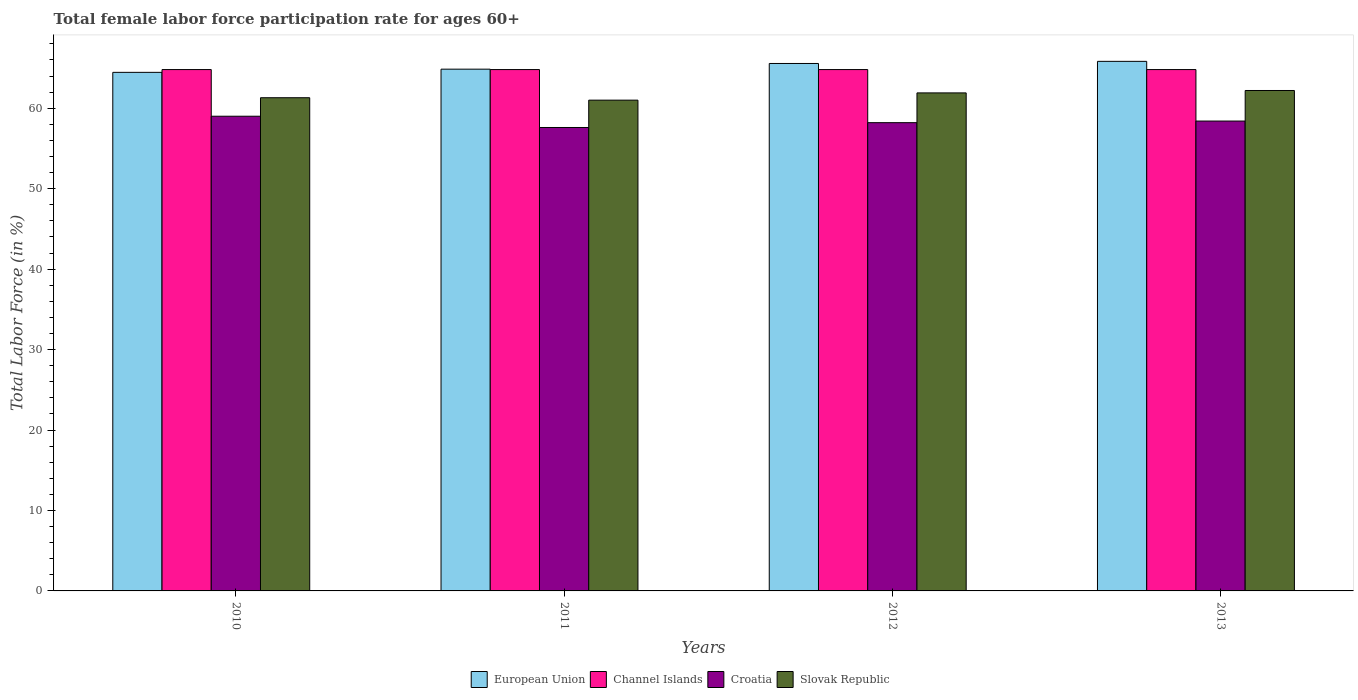How many different coloured bars are there?
Your answer should be very brief. 4. How many bars are there on the 2nd tick from the left?
Keep it short and to the point. 4. How many bars are there on the 2nd tick from the right?
Offer a very short reply. 4. What is the label of the 3rd group of bars from the left?
Your answer should be very brief. 2012. Across all years, what is the maximum female labor force participation rate in Slovak Republic?
Provide a succinct answer. 62.2. Across all years, what is the minimum female labor force participation rate in Croatia?
Offer a terse response. 57.6. In which year was the female labor force participation rate in Croatia maximum?
Ensure brevity in your answer.  2010. In which year was the female labor force participation rate in Croatia minimum?
Ensure brevity in your answer.  2011. What is the total female labor force participation rate in Channel Islands in the graph?
Offer a terse response. 259.2. What is the difference between the female labor force participation rate in European Union in 2011 and that in 2013?
Your response must be concise. -0.97. What is the difference between the female labor force participation rate in Channel Islands in 2010 and the female labor force participation rate in Croatia in 2013?
Your answer should be very brief. 6.4. What is the average female labor force participation rate in European Union per year?
Keep it short and to the point. 65.17. In the year 2012, what is the difference between the female labor force participation rate in Channel Islands and female labor force participation rate in European Union?
Your answer should be very brief. -0.76. In how many years, is the female labor force participation rate in Slovak Republic greater than 54 %?
Keep it short and to the point. 4. What is the ratio of the female labor force participation rate in Slovak Republic in 2010 to that in 2012?
Your response must be concise. 0.99. Is the female labor force participation rate in Slovak Republic in 2010 less than that in 2011?
Your answer should be compact. No. What is the difference between the highest and the second highest female labor force participation rate in Croatia?
Offer a terse response. 0.6. What is the difference between the highest and the lowest female labor force participation rate in Croatia?
Provide a short and direct response. 1.4. In how many years, is the female labor force participation rate in Channel Islands greater than the average female labor force participation rate in Channel Islands taken over all years?
Your answer should be compact. 0. Is the sum of the female labor force participation rate in Slovak Republic in 2010 and 2011 greater than the maximum female labor force participation rate in Channel Islands across all years?
Keep it short and to the point. Yes. What does the 4th bar from the left in 2010 represents?
Your response must be concise. Slovak Republic. Is it the case that in every year, the sum of the female labor force participation rate in European Union and female labor force participation rate in Slovak Republic is greater than the female labor force participation rate in Channel Islands?
Keep it short and to the point. Yes. Does the graph contain grids?
Give a very brief answer. No. What is the title of the graph?
Provide a short and direct response. Total female labor force participation rate for ages 60+. Does "Mexico" appear as one of the legend labels in the graph?
Make the answer very short. No. What is the label or title of the Y-axis?
Offer a terse response. Total Labor Force (in %). What is the Total Labor Force (in %) of European Union in 2010?
Make the answer very short. 64.45. What is the Total Labor Force (in %) of Channel Islands in 2010?
Provide a short and direct response. 64.8. What is the Total Labor Force (in %) of Croatia in 2010?
Your answer should be compact. 59. What is the Total Labor Force (in %) of Slovak Republic in 2010?
Offer a terse response. 61.3. What is the Total Labor Force (in %) of European Union in 2011?
Offer a very short reply. 64.85. What is the Total Labor Force (in %) in Channel Islands in 2011?
Ensure brevity in your answer.  64.8. What is the Total Labor Force (in %) in Croatia in 2011?
Ensure brevity in your answer.  57.6. What is the Total Labor Force (in %) in Slovak Republic in 2011?
Your answer should be very brief. 61. What is the Total Labor Force (in %) of European Union in 2012?
Offer a terse response. 65.56. What is the Total Labor Force (in %) of Channel Islands in 2012?
Give a very brief answer. 64.8. What is the Total Labor Force (in %) in Croatia in 2012?
Provide a succinct answer. 58.2. What is the Total Labor Force (in %) of Slovak Republic in 2012?
Your answer should be very brief. 61.9. What is the Total Labor Force (in %) in European Union in 2013?
Your answer should be very brief. 65.82. What is the Total Labor Force (in %) in Channel Islands in 2013?
Provide a short and direct response. 64.8. What is the Total Labor Force (in %) of Croatia in 2013?
Give a very brief answer. 58.4. What is the Total Labor Force (in %) of Slovak Republic in 2013?
Offer a terse response. 62.2. Across all years, what is the maximum Total Labor Force (in %) of European Union?
Your response must be concise. 65.82. Across all years, what is the maximum Total Labor Force (in %) in Channel Islands?
Give a very brief answer. 64.8. Across all years, what is the maximum Total Labor Force (in %) in Croatia?
Provide a succinct answer. 59. Across all years, what is the maximum Total Labor Force (in %) of Slovak Republic?
Keep it short and to the point. 62.2. Across all years, what is the minimum Total Labor Force (in %) in European Union?
Give a very brief answer. 64.45. Across all years, what is the minimum Total Labor Force (in %) of Channel Islands?
Provide a short and direct response. 64.8. Across all years, what is the minimum Total Labor Force (in %) of Croatia?
Give a very brief answer. 57.6. Across all years, what is the minimum Total Labor Force (in %) in Slovak Republic?
Provide a short and direct response. 61. What is the total Total Labor Force (in %) in European Union in the graph?
Ensure brevity in your answer.  260.68. What is the total Total Labor Force (in %) in Channel Islands in the graph?
Make the answer very short. 259.2. What is the total Total Labor Force (in %) of Croatia in the graph?
Keep it short and to the point. 233.2. What is the total Total Labor Force (in %) of Slovak Republic in the graph?
Provide a succinct answer. 246.4. What is the difference between the Total Labor Force (in %) of European Union in 2010 and that in 2011?
Your response must be concise. -0.39. What is the difference between the Total Labor Force (in %) of European Union in 2010 and that in 2012?
Your answer should be very brief. -1.1. What is the difference between the Total Labor Force (in %) in Croatia in 2010 and that in 2012?
Offer a terse response. 0.8. What is the difference between the Total Labor Force (in %) in European Union in 2010 and that in 2013?
Your answer should be very brief. -1.37. What is the difference between the Total Labor Force (in %) of Croatia in 2010 and that in 2013?
Give a very brief answer. 0.6. What is the difference between the Total Labor Force (in %) of European Union in 2011 and that in 2012?
Offer a very short reply. -0.71. What is the difference between the Total Labor Force (in %) of Channel Islands in 2011 and that in 2012?
Your response must be concise. 0. What is the difference between the Total Labor Force (in %) in European Union in 2011 and that in 2013?
Keep it short and to the point. -0.97. What is the difference between the Total Labor Force (in %) of European Union in 2012 and that in 2013?
Offer a terse response. -0.26. What is the difference between the Total Labor Force (in %) of Channel Islands in 2012 and that in 2013?
Offer a terse response. 0. What is the difference between the Total Labor Force (in %) of Croatia in 2012 and that in 2013?
Give a very brief answer. -0.2. What is the difference between the Total Labor Force (in %) of Slovak Republic in 2012 and that in 2013?
Ensure brevity in your answer.  -0.3. What is the difference between the Total Labor Force (in %) in European Union in 2010 and the Total Labor Force (in %) in Channel Islands in 2011?
Ensure brevity in your answer.  -0.35. What is the difference between the Total Labor Force (in %) of European Union in 2010 and the Total Labor Force (in %) of Croatia in 2011?
Provide a short and direct response. 6.85. What is the difference between the Total Labor Force (in %) in European Union in 2010 and the Total Labor Force (in %) in Slovak Republic in 2011?
Ensure brevity in your answer.  3.45. What is the difference between the Total Labor Force (in %) of Channel Islands in 2010 and the Total Labor Force (in %) of Slovak Republic in 2011?
Keep it short and to the point. 3.8. What is the difference between the Total Labor Force (in %) in Croatia in 2010 and the Total Labor Force (in %) in Slovak Republic in 2011?
Offer a very short reply. -2. What is the difference between the Total Labor Force (in %) in European Union in 2010 and the Total Labor Force (in %) in Channel Islands in 2012?
Give a very brief answer. -0.35. What is the difference between the Total Labor Force (in %) of European Union in 2010 and the Total Labor Force (in %) of Croatia in 2012?
Your response must be concise. 6.25. What is the difference between the Total Labor Force (in %) of European Union in 2010 and the Total Labor Force (in %) of Slovak Republic in 2012?
Your answer should be very brief. 2.55. What is the difference between the Total Labor Force (in %) of Channel Islands in 2010 and the Total Labor Force (in %) of Croatia in 2012?
Offer a terse response. 6.6. What is the difference between the Total Labor Force (in %) in Channel Islands in 2010 and the Total Labor Force (in %) in Slovak Republic in 2012?
Make the answer very short. 2.9. What is the difference between the Total Labor Force (in %) of Croatia in 2010 and the Total Labor Force (in %) of Slovak Republic in 2012?
Make the answer very short. -2.9. What is the difference between the Total Labor Force (in %) of European Union in 2010 and the Total Labor Force (in %) of Channel Islands in 2013?
Your answer should be compact. -0.35. What is the difference between the Total Labor Force (in %) of European Union in 2010 and the Total Labor Force (in %) of Croatia in 2013?
Provide a succinct answer. 6.05. What is the difference between the Total Labor Force (in %) of European Union in 2010 and the Total Labor Force (in %) of Slovak Republic in 2013?
Your answer should be compact. 2.25. What is the difference between the Total Labor Force (in %) in Channel Islands in 2010 and the Total Labor Force (in %) in Croatia in 2013?
Provide a short and direct response. 6.4. What is the difference between the Total Labor Force (in %) of Croatia in 2010 and the Total Labor Force (in %) of Slovak Republic in 2013?
Make the answer very short. -3.2. What is the difference between the Total Labor Force (in %) of European Union in 2011 and the Total Labor Force (in %) of Channel Islands in 2012?
Your answer should be very brief. 0.05. What is the difference between the Total Labor Force (in %) in European Union in 2011 and the Total Labor Force (in %) in Croatia in 2012?
Your response must be concise. 6.65. What is the difference between the Total Labor Force (in %) of European Union in 2011 and the Total Labor Force (in %) of Slovak Republic in 2012?
Provide a succinct answer. 2.95. What is the difference between the Total Labor Force (in %) of Channel Islands in 2011 and the Total Labor Force (in %) of Croatia in 2012?
Offer a terse response. 6.6. What is the difference between the Total Labor Force (in %) in Croatia in 2011 and the Total Labor Force (in %) in Slovak Republic in 2012?
Offer a terse response. -4.3. What is the difference between the Total Labor Force (in %) of European Union in 2011 and the Total Labor Force (in %) of Channel Islands in 2013?
Ensure brevity in your answer.  0.05. What is the difference between the Total Labor Force (in %) of European Union in 2011 and the Total Labor Force (in %) of Croatia in 2013?
Your answer should be compact. 6.45. What is the difference between the Total Labor Force (in %) in European Union in 2011 and the Total Labor Force (in %) in Slovak Republic in 2013?
Provide a short and direct response. 2.65. What is the difference between the Total Labor Force (in %) of Channel Islands in 2011 and the Total Labor Force (in %) of Croatia in 2013?
Your response must be concise. 6.4. What is the difference between the Total Labor Force (in %) of European Union in 2012 and the Total Labor Force (in %) of Channel Islands in 2013?
Keep it short and to the point. 0.76. What is the difference between the Total Labor Force (in %) of European Union in 2012 and the Total Labor Force (in %) of Croatia in 2013?
Provide a succinct answer. 7.16. What is the difference between the Total Labor Force (in %) in European Union in 2012 and the Total Labor Force (in %) in Slovak Republic in 2013?
Offer a terse response. 3.36. What is the difference between the Total Labor Force (in %) in Channel Islands in 2012 and the Total Labor Force (in %) in Croatia in 2013?
Keep it short and to the point. 6.4. What is the average Total Labor Force (in %) of European Union per year?
Provide a succinct answer. 65.17. What is the average Total Labor Force (in %) of Channel Islands per year?
Make the answer very short. 64.8. What is the average Total Labor Force (in %) of Croatia per year?
Provide a short and direct response. 58.3. What is the average Total Labor Force (in %) of Slovak Republic per year?
Give a very brief answer. 61.6. In the year 2010, what is the difference between the Total Labor Force (in %) in European Union and Total Labor Force (in %) in Channel Islands?
Make the answer very short. -0.35. In the year 2010, what is the difference between the Total Labor Force (in %) in European Union and Total Labor Force (in %) in Croatia?
Keep it short and to the point. 5.45. In the year 2010, what is the difference between the Total Labor Force (in %) of European Union and Total Labor Force (in %) of Slovak Republic?
Provide a succinct answer. 3.15. In the year 2010, what is the difference between the Total Labor Force (in %) of Channel Islands and Total Labor Force (in %) of Slovak Republic?
Make the answer very short. 3.5. In the year 2010, what is the difference between the Total Labor Force (in %) of Croatia and Total Labor Force (in %) of Slovak Republic?
Your answer should be compact. -2.3. In the year 2011, what is the difference between the Total Labor Force (in %) of European Union and Total Labor Force (in %) of Channel Islands?
Provide a succinct answer. 0.05. In the year 2011, what is the difference between the Total Labor Force (in %) in European Union and Total Labor Force (in %) in Croatia?
Provide a short and direct response. 7.25. In the year 2011, what is the difference between the Total Labor Force (in %) in European Union and Total Labor Force (in %) in Slovak Republic?
Your response must be concise. 3.85. In the year 2011, what is the difference between the Total Labor Force (in %) of Channel Islands and Total Labor Force (in %) of Croatia?
Your answer should be compact. 7.2. In the year 2011, what is the difference between the Total Labor Force (in %) in Croatia and Total Labor Force (in %) in Slovak Republic?
Offer a very short reply. -3.4. In the year 2012, what is the difference between the Total Labor Force (in %) of European Union and Total Labor Force (in %) of Channel Islands?
Make the answer very short. 0.76. In the year 2012, what is the difference between the Total Labor Force (in %) in European Union and Total Labor Force (in %) in Croatia?
Keep it short and to the point. 7.36. In the year 2012, what is the difference between the Total Labor Force (in %) of European Union and Total Labor Force (in %) of Slovak Republic?
Your response must be concise. 3.66. In the year 2012, what is the difference between the Total Labor Force (in %) of Channel Islands and Total Labor Force (in %) of Slovak Republic?
Make the answer very short. 2.9. In the year 2012, what is the difference between the Total Labor Force (in %) in Croatia and Total Labor Force (in %) in Slovak Republic?
Offer a very short reply. -3.7. In the year 2013, what is the difference between the Total Labor Force (in %) of European Union and Total Labor Force (in %) of Croatia?
Your response must be concise. 7.42. In the year 2013, what is the difference between the Total Labor Force (in %) in European Union and Total Labor Force (in %) in Slovak Republic?
Make the answer very short. 3.62. What is the ratio of the Total Labor Force (in %) in Croatia in 2010 to that in 2011?
Keep it short and to the point. 1.02. What is the ratio of the Total Labor Force (in %) in Slovak Republic in 2010 to that in 2011?
Your answer should be very brief. 1. What is the ratio of the Total Labor Force (in %) in European Union in 2010 to that in 2012?
Keep it short and to the point. 0.98. What is the ratio of the Total Labor Force (in %) of Channel Islands in 2010 to that in 2012?
Provide a succinct answer. 1. What is the ratio of the Total Labor Force (in %) in Croatia in 2010 to that in 2012?
Keep it short and to the point. 1.01. What is the ratio of the Total Labor Force (in %) in Slovak Republic in 2010 to that in 2012?
Offer a very short reply. 0.99. What is the ratio of the Total Labor Force (in %) in European Union in 2010 to that in 2013?
Make the answer very short. 0.98. What is the ratio of the Total Labor Force (in %) of Croatia in 2010 to that in 2013?
Give a very brief answer. 1.01. What is the ratio of the Total Labor Force (in %) of Slovak Republic in 2010 to that in 2013?
Give a very brief answer. 0.99. What is the ratio of the Total Labor Force (in %) of Slovak Republic in 2011 to that in 2012?
Make the answer very short. 0.99. What is the ratio of the Total Labor Force (in %) of European Union in 2011 to that in 2013?
Give a very brief answer. 0.99. What is the ratio of the Total Labor Force (in %) of Channel Islands in 2011 to that in 2013?
Provide a short and direct response. 1. What is the ratio of the Total Labor Force (in %) of Croatia in 2011 to that in 2013?
Provide a short and direct response. 0.99. What is the ratio of the Total Labor Force (in %) of Slovak Republic in 2011 to that in 2013?
Provide a succinct answer. 0.98. What is the ratio of the Total Labor Force (in %) in European Union in 2012 to that in 2013?
Give a very brief answer. 1. What is the ratio of the Total Labor Force (in %) in Slovak Republic in 2012 to that in 2013?
Make the answer very short. 1. What is the difference between the highest and the second highest Total Labor Force (in %) in European Union?
Offer a very short reply. 0.26. What is the difference between the highest and the second highest Total Labor Force (in %) of Croatia?
Provide a short and direct response. 0.6. What is the difference between the highest and the second highest Total Labor Force (in %) of Slovak Republic?
Give a very brief answer. 0.3. What is the difference between the highest and the lowest Total Labor Force (in %) in European Union?
Offer a very short reply. 1.37. What is the difference between the highest and the lowest Total Labor Force (in %) of Channel Islands?
Provide a succinct answer. 0. 